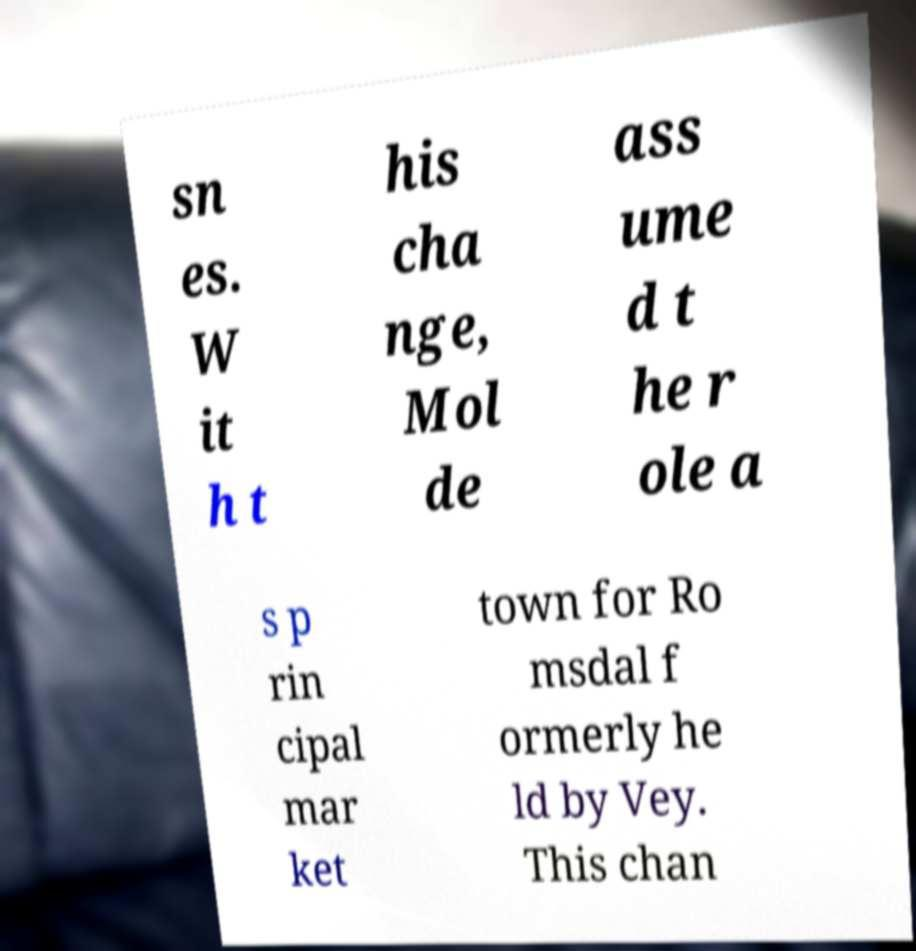What messages or text are displayed in this image? I need them in a readable, typed format. sn es. W it h t his cha nge, Mol de ass ume d t he r ole a s p rin cipal mar ket town for Ro msdal f ormerly he ld by Vey. This chan 